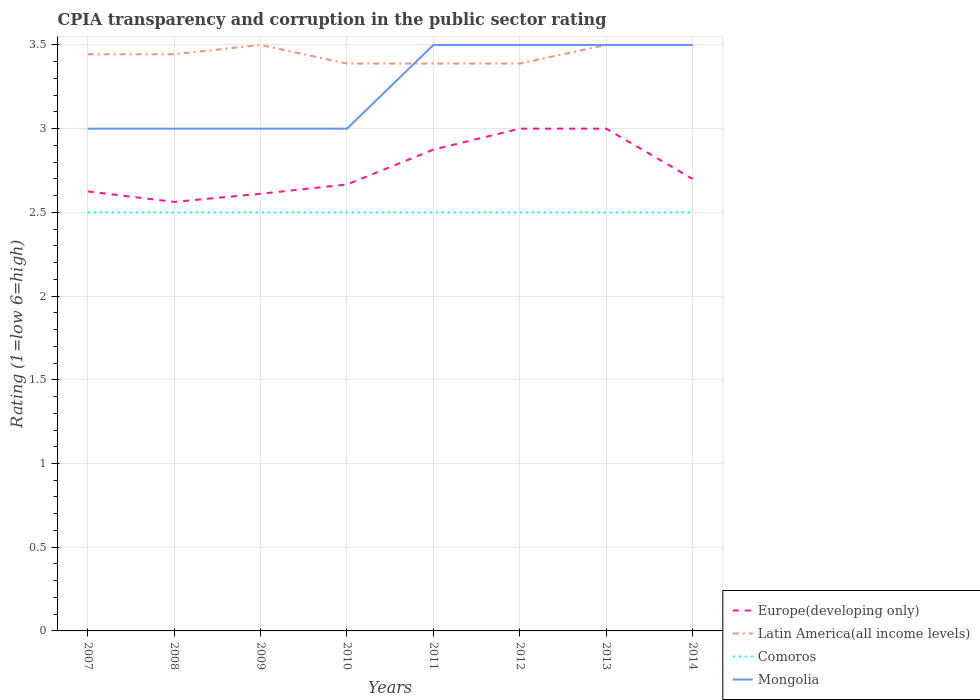How many different coloured lines are there?
Make the answer very short. 4. Does the line corresponding to Comoros intersect with the line corresponding to Latin America(all income levels)?
Provide a succinct answer. No. In which year was the CPIA rating in Latin America(all income levels) maximum?
Your answer should be compact. 2010. What is the difference between the highest and the second highest CPIA rating in Comoros?
Provide a short and direct response. 0. What is the difference between the highest and the lowest CPIA rating in Europe(developing only)?
Your answer should be compact. 3. What is the difference between two consecutive major ticks on the Y-axis?
Your response must be concise. 0.5. Where does the legend appear in the graph?
Your answer should be very brief. Bottom right. How many legend labels are there?
Your response must be concise. 4. How are the legend labels stacked?
Provide a short and direct response. Vertical. What is the title of the graph?
Keep it short and to the point. CPIA transparency and corruption in the public sector rating. What is the label or title of the X-axis?
Your answer should be very brief. Years. What is the Rating (1=low 6=high) of Europe(developing only) in 2007?
Provide a short and direct response. 2.62. What is the Rating (1=low 6=high) in Latin America(all income levels) in 2007?
Your answer should be compact. 3.44. What is the Rating (1=low 6=high) in Comoros in 2007?
Provide a succinct answer. 2.5. What is the Rating (1=low 6=high) in Mongolia in 2007?
Your answer should be compact. 3. What is the Rating (1=low 6=high) of Europe(developing only) in 2008?
Ensure brevity in your answer.  2.56. What is the Rating (1=low 6=high) of Latin America(all income levels) in 2008?
Give a very brief answer. 3.44. What is the Rating (1=low 6=high) of Comoros in 2008?
Give a very brief answer. 2.5. What is the Rating (1=low 6=high) in Mongolia in 2008?
Your response must be concise. 3. What is the Rating (1=low 6=high) in Europe(developing only) in 2009?
Your answer should be very brief. 2.61. What is the Rating (1=low 6=high) in Latin America(all income levels) in 2009?
Provide a succinct answer. 3.5. What is the Rating (1=low 6=high) in Europe(developing only) in 2010?
Offer a terse response. 2.67. What is the Rating (1=low 6=high) of Latin America(all income levels) in 2010?
Provide a succinct answer. 3.39. What is the Rating (1=low 6=high) of Mongolia in 2010?
Your response must be concise. 3. What is the Rating (1=low 6=high) of Europe(developing only) in 2011?
Provide a short and direct response. 2.88. What is the Rating (1=low 6=high) in Latin America(all income levels) in 2011?
Make the answer very short. 3.39. What is the Rating (1=low 6=high) of Europe(developing only) in 2012?
Make the answer very short. 3. What is the Rating (1=low 6=high) of Latin America(all income levels) in 2012?
Offer a terse response. 3.39. What is the Rating (1=low 6=high) of Comoros in 2012?
Your answer should be very brief. 2.5. What is the Rating (1=low 6=high) in Mongolia in 2012?
Provide a short and direct response. 3.5. What is the Rating (1=low 6=high) of Europe(developing only) in 2013?
Offer a very short reply. 3. What is the Rating (1=low 6=high) in Latin America(all income levels) in 2013?
Keep it short and to the point. 3.5. What is the Rating (1=low 6=high) of Europe(developing only) in 2014?
Your response must be concise. 2.7. What is the Rating (1=low 6=high) of Latin America(all income levels) in 2014?
Provide a succinct answer. 3.5. Across all years, what is the minimum Rating (1=low 6=high) of Europe(developing only)?
Your answer should be compact. 2.56. Across all years, what is the minimum Rating (1=low 6=high) in Latin America(all income levels)?
Offer a terse response. 3.39. Across all years, what is the minimum Rating (1=low 6=high) in Mongolia?
Provide a short and direct response. 3. What is the total Rating (1=low 6=high) of Europe(developing only) in the graph?
Your answer should be compact. 22.04. What is the total Rating (1=low 6=high) in Latin America(all income levels) in the graph?
Your response must be concise. 27.56. What is the difference between the Rating (1=low 6=high) in Europe(developing only) in 2007 and that in 2008?
Offer a very short reply. 0.06. What is the difference between the Rating (1=low 6=high) of Latin America(all income levels) in 2007 and that in 2008?
Provide a short and direct response. 0. What is the difference between the Rating (1=low 6=high) in Europe(developing only) in 2007 and that in 2009?
Provide a succinct answer. 0.01. What is the difference between the Rating (1=low 6=high) of Latin America(all income levels) in 2007 and that in 2009?
Ensure brevity in your answer.  -0.06. What is the difference between the Rating (1=low 6=high) of Europe(developing only) in 2007 and that in 2010?
Provide a succinct answer. -0.04. What is the difference between the Rating (1=low 6=high) of Latin America(all income levels) in 2007 and that in 2010?
Provide a succinct answer. 0.06. What is the difference between the Rating (1=low 6=high) in Comoros in 2007 and that in 2010?
Your answer should be compact. 0. What is the difference between the Rating (1=low 6=high) in Mongolia in 2007 and that in 2010?
Provide a short and direct response. 0. What is the difference between the Rating (1=low 6=high) in Europe(developing only) in 2007 and that in 2011?
Offer a terse response. -0.25. What is the difference between the Rating (1=low 6=high) in Latin America(all income levels) in 2007 and that in 2011?
Provide a short and direct response. 0.06. What is the difference between the Rating (1=low 6=high) of Comoros in 2007 and that in 2011?
Offer a very short reply. 0. What is the difference between the Rating (1=low 6=high) in Mongolia in 2007 and that in 2011?
Your response must be concise. -0.5. What is the difference between the Rating (1=low 6=high) in Europe(developing only) in 2007 and that in 2012?
Your answer should be very brief. -0.38. What is the difference between the Rating (1=low 6=high) of Latin America(all income levels) in 2007 and that in 2012?
Offer a terse response. 0.06. What is the difference between the Rating (1=low 6=high) of Comoros in 2007 and that in 2012?
Offer a terse response. 0. What is the difference between the Rating (1=low 6=high) in Mongolia in 2007 and that in 2012?
Your answer should be very brief. -0.5. What is the difference between the Rating (1=low 6=high) in Europe(developing only) in 2007 and that in 2013?
Provide a succinct answer. -0.38. What is the difference between the Rating (1=low 6=high) of Latin America(all income levels) in 2007 and that in 2013?
Give a very brief answer. -0.06. What is the difference between the Rating (1=low 6=high) of Comoros in 2007 and that in 2013?
Make the answer very short. 0. What is the difference between the Rating (1=low 6=high) of Europe(developing only) in 2007 and that in 2014?
Your response must be concise. -0.07. What is the difference between the Rating (1=low 6=high) of Latin America(all income levels) in 2007 and that in 2014?
Keep it short and to the point. -0.06. What is the difference between the Rating (1=low 6=high) in Mongolia in 2007 and that in 2014?
Your response must be concise. -0.5. What is the difference between the Rating (1=low 6=high) of Europe(developing only) in 2008 and that in 2009?
Your response must be concise. -0.05. What is the difference between the Rating (1=low 6=high) in Latin America(all income levels) in 2008 and that in 2009?
Make the answer very short. -0.06. What is the difference between the Rating (1=low 6=high) in Europe(developing only) in 2008 and that in 2010?
Your answer should be very brief. -0.1. What is the difference between the Rating (1=low 6=high) in Latin America(all income levels) in 2008 and that in 2010?
Give a very brief answer. 0.06. What is the difference between the Rating (1=low 6=high) of Europe(developing only) in 2008 and that in 2011?
Offer a terse response. -0.31. What is the difference between the Rating (1=low 6=high) of Latin America(all income levels) in 2008 and that in 2011?
Offer a terse response. 0.06. What is the difference between the Rating (1=low 6=high) of Europe(developing only) in 2008 and that in 2012?
Offer a terse response. -0.44. What is the difference between the Rating (1=low 6=high) in Latin America(all income levels) in 2008 and that in 2012?
Offer a terse response. 0.06. What is the difference between the Rating (1=low 6=high) in Comoros in 2008 and that in 2012?
Ensure brevity in your answer.  0. What is the difference between the Rating (1=low 6=high) in Mongolia in 2008 and that in 2012?
Your answer should be compact. -0.5. What is the difference between the Rating (1=low 6=high) in Europe(developing only) in 2008 and that in 2013?
Offer a terse response. -0.44. What is the difference between the Rating (1=low 6=high) in Latin America(all income levels) in 2008 and that in 2013?
Your answer should be very brief. -0.06. What is the difference between the Rating (1=low 6=high) of Mongolia in 2008 and that in 2013?
Your answer should be compact. -0.5. What is the difference between the Rating (1=low 6=high) of Europe(developing only) in 2008 and that in 2014?
Provide a short and direct response. -0.14. What is the difference between the Rating (1=low 6=high) in Latin America(all income levels) in 2008 and that in 2014?
Provide a succinct answer. -0.06. What is the difference between the Rating (1=low 6=high) in Mongolia in 2008 and that in 2014?
Ensure brevity in your answer.  -0.5. What is the difference between the Rating (1=low 6=high) in Europe(developing only) in 2009 and that in 2010?
Offer a terse response. -0.06. What is the difference between the Rating (1=low 6=high) in Latin America(all income levels) in 2009 and that in 2010?
Provide a short and direct response. 0.11. What is the difference between the Rating (1=low 6=high) of Comoros in 2009 and that in 2010?
Keep it short and to the point. 0. What is the difference between the Rating (1=low 6=high) of Mongolia in 2009 and that in 2010?
Ensure brevity in your answer.  0. What is the difference between the Rating (1=low 6=high) in Europe(developing only) in 2009 and that in 2011?
Keep it short and to the point. -0.26. What is the difference between the Rating (1=low 6=high) of Latin America(all income levels) in 2009 and that in 2011?
Offer a terse response. 0.11. What is the difference between the Rating (1=low 6=high) of Europe(developing only) in 2009 and that in 2012?
Offer a very short reply. -0.39. What is the difference between the Rating (1=low 6=high) in Comoros in 2009 and that in 2012?
Give a very brief answer. 0. What is the difference between the Rating (1=low 6=high) of Europe(developing only) in 2009 and that in 2013?
Keep it short and to the point. -0.39. What is the difference between the Rating (1=low 6=high) of Latin America(all income levels) in 2009 and that in 2013?
Make the answer very short. 0. What is the difference between the Rating (1=low 6=high) in Comoros in 2009 and that in 2013?
Your answer should be very brief. 0. What is the difference between the Rating (1=low 6=high) in Europe(developing only) in 2009 and that in 2014?
Keep it short and to the point. -0.09. What is the difference between the Rating (1=low 6=high) in Latin America(all income levels) in 2009 and that in 2014?
Offer a very short reply. 0. What is the difference between the Rating (1=low 6=high) in Europe(developing only) in 2010 and that in 2011?
Offer a terse response. -0.21. What is the difference between the Rating (1=low 6=high) in Mongolia in 2010 and that in 2011?
Make the answer very short. -0.5. What is the difference between the Rating (1=low 6=high) in Mongolia in 2010 and that in 2012?
Provide a succinct answer. -0.5. What is the difference between the Rating (1=low 6=high) in Latin America(all income levels) in 2010 and that in 2013?
Provide a short and direct response. -0.11. What is the difference between the Rating (1=low 6=high) in Comoros in 2010 and that in 2013?
Make the answer very short. 0. What is the difference between the Rating (1=low 6=high) in Europe(developing only) in 2010 and that in 2014?
Ensure brevity in your answer.  -0.03. What is the difference between the Rating (1=low 6=high) in Latin America(all income levels) in 2010 and that in 2014?
Your response must be concise. -0.11. What is the difference between the Rating (1=low 6=high) in Europe(developing only) in 2011 and that in 2012?
Give a very brief answer. -0.12. What is the difference between the Rating (1=low 6=high) of Comoros in 2011 and that in 2012?
Your answer should be very brief. 0. What is the difference between the Rating (1=low 6=high) of Europe(developing only) in 2011 and that in 2013?
Offer a very short reply. -0.12. What is the difference between the Rating (1=low 6=high) of Latin America(all income levels) in 2011 and that in 2013?
Provide a succinct answer. -0.11. What is the difference between the Rating (1=low 6=high) of Comoros in 2011 and that in 2013?
Ensure brevity in your answer.  0. What is the difference between the Rating (1=low 6=high) of Mongolia in 2011 and that in 2013?
Provide a short and direct response. 0. What is the difference between the Rating (1=low 6=high) in Europe(developing only) in 2011 and that in 2014?
Your answer should be compact. 0.17. What is the difference between the Rating (1=low 6=high) of Latin America(all income levels) in 2011 and that in 2014?
Keep it short and to the point. -0.11. What is the difference between the Rating (1=low 6=high) of Comoros in 2011 and that in 2014?
Your answer should be very brief. 0. What is the difference between the Rating (1=low 6=high) in Latin America(all income levels) in 2012 and that in 2013?
Ensure brevity in your answer.  -0.11. What is the difference between the Rating (1=low 6=high) in Mongolia in 2012 and that in 2013?
Your answer should be very brief. 0. What is the difference between the Rating (1=low 6=high) in Latin America(all income levels) in 2012 and that in 2014?
Offer a terse response. -0.11. What is the difference between the Rating (1=low 6=high) in Comoros in 2012 and that in 2014?
Offer a terse response. 0. What is the difference between the Rating (1=low 6=high) of Mongolia in 2012 and that in 2014?
Your answer should be compact. 0. What is the difference between the Rating (1=low 6=high) in Europe(developing only) in 2013 and that in 2014?
Offer a terse response. 0.3. What is the difference between the Rating (1=low 6=high) of Latin America(all income levels) in 2013 and that in 2014?
Your response must be concise. 0. What is the difference between the Rating (1=low 6=high) of Europe(developing only) in 2007 and the Rating (1=low 6=high) of Latin America(all income levels) in 2008?
Ensure brevity in your answer.  -0.82. What is the difference between the Rating (1=low 6=high) in Europe(developing only) in 2007 and the Rating (1=low 6=high) in Comoros in 2008?
Offer a very short reply. 0.12. What is the difference between the Rating (1=low 6=high) in Europe(developing only) in 2007 and the Rating (1=low 6=high) in Mongolia in 2008?
Provide a short and direct response. -0.38. What is the difference between the Rating (1=low 6=high) in Latin America(all income levels) in 2007 and the Rating (1=low 6=high) in Mongolia in 2008?
Your answer should be compact. 0.44. What is the difference between the Rating (1=low 6=high) of Europe(developing only) in 2007 and the Rating (1=low 6=high) of Latin America(all income levels) in 2009?
Offer a terse response. -0.88. What is the difference between the Rating (1=low 6=high) of Europe(developing only) in 2007 and the Rating (1=low 6=high) of Comoros in 2009?
Your answer should be compact. 0.12. What is the difference between the Rating (1=low 6=high) of Europe(developing only) in 2007 and the Rating (1=low 6=high) of Mongolia in 2009?
Your answer should be compact. -0.38. What is the difference between the Rating (1=low 6=high) in Latin America(all income levels) in 2007 and the Rating (1=low 6=high) in Comoros in 2009?
Your response must be concise. 0.94. What is the difference between the Rating (1=low 6=high) in Latin America(all income levels) in 2007 and the Rating (1=low 6=high) in Mongolia in 2009?
Your answer should be very brief. 0.44. What is the difference between the Rating (1=low 6=high) in Comoros in 2007 and the Rating (1=low 6=high) in Mongolia in 2009?
Provide a succinct answer. -0.5. What is the difference between the Rating (1=low 6=high) of Europe(developing only) in 2007 and the Rating (1=low 6=high) of Latin America(all income levels) in 2010?
Ensure brevity in your answer.  -0.76. What is the difference between the Rating (1=low 6=high) in Europe(developing only) in 2007 and the Rating (1=low 6=high) in Mongolia in 2010?
Keep it short and to the point. -0.38. What is the difference between the Rating (1=low 6=high) of Latin America(all income levels) in 2007 and the Rating (1=low 6=high) of Mongolia in 2010?
Give a very brief answer. 0.44. What is the difference between the Rating (1=low 6=high) of Comoros in 2007 and the Rating (1=low 6=high) of Mongolia in 2010?
Ensure brevity in your answer.  -0.5. What is the difference between the Rating (1=low 6=high) in Europe(developing only) in 2007 and the Rating (1=low 6=high) in Latin America(all income levels) in 2011?
Your answer should be compact. -0.76. What is the difference between the Rating (1=low 6=high) of Europe(developing only) in 2007 and the Rating (1=low 6=high) of Comoros in 2011?
Give a very brief answer. 0.12. What is the difference between the Rating (1=low 6=high) of Europe(developing only) in 2007 and the Rating (1=low 6=high) of Mongolia in 2011?
Make the answer very short. -0.88. What is the difference between the Rating (1=low 6=high) of Latin America(all income levels) in 2007 and the Rating (1=low 6=high) of Comoros in 2011?
Offer a terse response. 0.94. What is the difference between the Rating (1=low 6=high) in Latin America(all income levels) in 2007 and the Rating (1=low 6=high) in Mongolia in 2011?
Your answer should be compact. -0.06. What is the difference between the Rating (1=low 6=high) of Europe(developing only) in 2007 and the Rating (1=low 6=high) of Latin America(all income levels) in 2012?
Give a very brief answer. -0.76. What is the difference between the Rating (1=low 6=high) in Europe(developing only) in 2007 and the Rating (1=low 6=high) in Mongolia in 2012?
Ensure brevity in your answer.  -0.88. What is the difference between the Rating (1=low 6=high) in Latin America(all income levels) in 2007 and the Rating (1=low 6=high) in Comoros in 2012?
Provide a short and direct response. 0.94. What is the difference between the Rating (1=low 6=high) in Latin America(all income levels) in 2007 and the Rating (1=low 6=high) in Mongolia in 2012?
Your answer should be compact. -0.06. What is the difference between the Rating (1=low 6=high) in Comoros in 2007 and the Rating (1=low 6=high) in Mongolia in 2012?
Your answer should be very brief. -1. What is the difference between the Rating (1=low 6=high) of Europe(developing only) in 2007 and the Rating (1=low 6=high) of Latin America(all income levels) in 2013?
Your answer should be very brief. -0.88. What is the difference between the Rating (1=low 6=high) of Europe(developing only) in 2007 and the Rating (1=low 6=high) of Mongolia in 2013?
Provide a short and direct response. -0.88. What is the difference between the Rating (1=low 6=high) in Latin America(all income levels) in 2007 and the Rating (1=low 6=high) in Comoros in 2013?
Your answer should be very brief. 0.94. What is the difference between the Rating (1=low 6=high) in Latin America(all income levels) in 2007 and the Rating (1=low 6=high) in Mongolia in 2013?
Ensure brevity in your answer.  -0.06. What is the difference between the Rating (1=low 6=high) of Europe(developing only) in 2007 and the Rating (1=low 6=high) of Latin America(all income levels) in 2014?
Give a very brief answer. -0.88. What is the difference between the Rating (1=low 6=high) in Europe(developing only) in 2007 and the Rating (1=low 6=high) in Comoros in 2014?
Keep it short and to the point. 0.12. What is the difference between the Rating (1=low 6=high) in Europe(developing only) in 2007 and the Rating (1=low 6=high) in Mongolia in 2014?
Your answer should be very brief. -0.88. What is the difference between the Rating (1=low 6=high) of Latin America(all income levels) in 2007 and the Rating (1=low 6=high) of Mongolia in 2014?
Ensure brevity in your answer.  -0.06. What is the difference between the Rating (1=low 6=high) in Europe(developing only) in 2008 and the Rating (1=low 6=high) in Latin America(all income levels) in 2009?
Your response must be concise. -0.94. What is the difference between the Rating (1=low 6=high) of Europe(developing only) in 2008 and the Rating (1=low 6=high) of Comoros in 2009?
Keep it short and to the point. 0.06. What is the difference between the Rating (1=low 6=high) in Europe(developing only) in 2008 and the Rating (1=low 6=high) in Mongolia in 2009?
Offer a terse response. -0.44. What is the difference between the Rating (1=low 6=high) in Latin America(all income levels) in 2008 and the Rating (1=low 6=high) in Mongolia in 2009?
Keep it short and to the point. 0.44. What is the difference between the Rating (1=low 6=high) in Europe(developing only) in 2008 and the Rating (1=low 6=high) in Latin America(all income levels) in 2010?
Your response must be concise. -0.83. What is the difference between the Rating (1=low 6=high) of Europe(developing only) in 2008 and the Rating (1=low 6=high) of Comoros in 2010?
Give a very brief answer. 0.06. What is the difference between the Rating (1=low 6=high) in Europe(developing only) in 2008 and the Rating (1=low 6=high) in Mongolia in 2010?
Your response must be concise. -0.44. What is the difference between the Rating (1=low 6=high) in Latin America(all income levels) in 2008 and the Rating (1=low 6=high) in Comoros in 2010?
Give a very brief answer. 0.94. What is the difference between the Rating (1=low 6=high) of Latin America(all income levels) in 2008 and the Rating (1=low 6=high) of Mongolia in 2010?
Provide a succinct answer. 0.44. What is the difference between the Rating (1=low 6=high) in Europe(developing only) in 2008 and the Rating (1=low 6=high) in Latin America(all income levels) in 2011?
Your response must be concise. -0.83. What is the difference between the Rating (1=low 6=high) of Europe(developing only) in 2008 and the Rating (1=low 6=high) of Comoros in 2011?
Provide a succinct answer. 0.06. What is the difference between the Rating (1=low 6=high) in Europe(developing only) in 2008 and the Rating (1=low 6=high) in Mongolia in 2011?
Make the answer very short. -0.94. What is the difference between the Rating (1=low 6=high) of Latin America(all income levels) in 2008 and the Rating (1=low 6=high) of Comoros in 2011?
Ensure brevity in your answer.  0.94. What is the difference between the Rating (1=low 6=high) of Latin America(all income levels) in 2008 and the Rating (1=low 6=high) of Mongolia in 2011?
Your answer should be compact. -0.06. What is the difference between the Rating (1=low 6=high) in Comoros in 2008 and the Rating (1=low 6=high) in Mongolia in 2011?
Your answer should be compact. -1. What is the difference between the Rating (1=low 6=high) of Europe(developing only) in 2008 and the Rating (1=low 6=high) of Latin America(all income levels) in 2012?
Ensure brevity in your answer.  -0.83. What is the difference between the Rating (1=low 6=high) in Europe(developing only) in 2008 and the Rating (1=low 6=high) in Comoros in 2012?
Your answer should be very brief. 0.06. What is the difference between the Rating (1=low 6=high) in Europe(developing only) in 2008 and the Rating (1=low 6=high) in Mongolia in 2012?
Keep it short and to the point. -0.94. What is the difference between the Rating (1=low 6=high) in Latin America(all income levels) in 2008 and the Rating (1=low 6=high) in Comoros in 2012?
Your answer should be very brief. 0.94. What is the difference between the Rating (1=low 6=high) of Latin America(all income levels) in 2008 and the Rating (1=low 6=high) of Mongolia in 2012?
Your answer should be very brief. -0.06. What is the difference between the Rating (1=low 6=high) of Comoros in 2008 and the Rating (1=low 6=high) of Mongolia in 2012?
Keep it short and to the point. -1. What is the difference between the Rating (1=low 6=high) of Europe(developing only) in 2008 and the Rating (1=low 6=high) of Latin America(all income levels) in 2013?
Give a very brief answer. -0.94. What is the difference between the Rating (1=low 6=high) in Europe(developing only) in 2008 and the Rating (1=low 6=high) in Comoros in 2013?
Your response must be concise. 0.06. What is the difference between the Rating (1=low 6=high) in Europe(developing only) in 2008 and the Rating (1=low 6=high) in Mongolia in 2013?
Your response must be concise. -0.94. What is the difference between the Rating (1=low 6=high) in Latin America(all income levels) in 2008 and the Rating (1=low 6=high) in Comoros in 2013?
Provide a succinct answer. 0.94. What is the difference between the Rating (1=low 6=high) of Latin America(all income levels) in 2008 and the Rating (1=low 6=high) of Mongolia in 2013?
Your answer should be very brief. -0.06. What is the difference between the Rating (1=low 6=high) in Comoros in 2008 and the Rating (1=low 6=high) in Mongolia in 2013?
Offer a terse response. -1. What is the difference between the Rating (1=low 6=high) in Europe(developing only) in 2008 and the Rating (1=low 6=high) in Latin America(all income levels) in 2014?
Offer a terse response. -0.94. What is the difference between the Rating (1=low 6=high) in Europe(developing only) in 2008 and the Rating (1=low 6=high) in Comoros in 2014?
Your answer should be very brief. 0.06. What is the difference between the Rating (1=low 6=high) of Europe(developing only) in 2008 and the Rating (1=low 6=high) of Mongolia in 2014?
Give a very brief answer. -0.94. What is the difference between the Rating (1=low 6=high) in Latin America(all income levels) in 2008 and the Rating (1=low 6=high) in Mongolia in 2014?
Ensure brevity in your answer.  -0.06. What is the difference between the Rating (1=low 6=high) of Europe(developing only) in 2009 and the Rating (1=low 6=high) of Latin America(all income levels) in 2010?
Provide a short and direct response. -0.78. What is the difference between the Rating (1=low 6=high) in Europe(developing only) in 2009 and the Rating (1=low 6=high) in Comoros in 2010?
Make the answer very short. 0.11. What is the difference between the Rating (1=low 6=high) in Europe(developing only) in 2009 and the Rating (1=low 6=high) in Mongolia in 2010?
Your answer should be very brief. -0.39. What is the difference between the Rating (1=low 6=high) in Latin America(all income levels) in 2009 and the Rating (1=low 6=high) in Comoros in 2010?
Give a very brief answer. 1. What is the difference between the Rating (1=low 6=high) in Comoros in 2009 and the Rating (1=low 6=high) in Mongolia in 2010?
Your answer should be compact. -0.5. What is the difference between the Rating (1=low 6=high) of Europe(developing only) in 2009 and the Rating (1=low 6=high) of Latin America(all income levels) in 2011?
Your answer should be compact. -0.78. What is the difference between the Rating (1=low 6=high) of Europe(developing only) in 2009 and the Rating (1=low 6=high) of Mongolia in 2011?
Offer a terse response. -0.89. What is the difference between the Rating (1=low 6=high) in Europe(developing only) in 2009 and the Rating (1=low 6=high) in Latin America(all income levels) in 2012?
Provide a short and direct response. -0.78. What is the difference between the Rating (1=low 6=high) of Europe(developing only) in 2009 and the Rating (1=low 6=high) of Mongolia in 2012?
Give a very brief answer. -0.89. What is the difference between the Rating (1=low 6=high) in Latin America(all income levels) in 2009 and the Rating (1=low 6=high) in Comoros in 2012?
Keep it short and to the point. 1. What is the difference between the Rating (1=low 6=high) of Europe(developing only) in 2009 and the Rating (1=low 6=high) of Latin America(all income levels) in 2013?
Provide a succinct answer. -0.89. What is the difference between the Rating (1=low 6=high) in Europe(developing only) in 2009 and the Rating (1=low 6=high) in Mongolia in 2013?
Your answer should be compact. -0.89. What is the difference between the Rating (1=low 6=high) in Latin America(all income levels) in 2009 and the Rating (1=low 6=high) in Mongolia in 2013?
Offer a terse response. 0. What is the difference between the Rating (1=low 6=high) of Comoros in 2009 and the Rating (1=low 6=high) of Mongolia in 2013?
Ensure brevity in your answer.  -1. What is the difference between the Rating (1=low 6=high) in Europe(developing only) in 2009 and the Rating (1=low 6=high) in Latin America(all income levels) in 2014?
Your response must be concise. -0.89. What is the difference between the Rating (1=low 6=high) in Europe(developing only) in 2009 and the Rating (1=low 6=high) in Mongolia in 2014?
Keep it short and to the point. -0.89. What is the difference between the Rating (1=low 6=high) in Latin America(all income levels) in 2009 and the Rating (1=low 6=high) in Mongolia in 2014?
Offer a terse response. 0. What is the difference between the Rating (1=low 6=high) in Europe(developing only) in 2010 and the Rating (1=low 6=high) in Latin America(all income levels) in 2011?
Offer a very short reply. -0.72. What is the difference between the Rating (1=low 6=high) in Europe(developing only) in 2010 and the Rating (1=low 6=high) in Comoros in 2011?
Offer a very short reply. 0.17. What is the difference between the Rating (1=low 6=high) in Europe(developing only) in 2010 and the Rating (1=low 6=high) in Mongolia in 2011?
Give a very brief answer. -0.83. What is the difference between the Rating (1=low 6=high) in Latin America(all income levels) in 2010 and the Rating (1=low 6=high) in Comoros in 2011?
Provide a short and direct response. 0.89. What is the difference between the Rating (1=low 6=high) in Latin America(all income levels) in 2010 and the Rating (1=low 6=high) in Mongolia in 2011?
Offer a terse response. -0.11. What is the difference between the Rating (1=low 6=high) of Comoros in 2010 and the Rating (1=low 6=high) of Mongolia in 2011?
Your answer should be very brief. -1. What is the difference between the Rating (1=low 6=high) of Europe(developing only) in 2010 and the Rating (1=low 6=high) of Latin America(all income levels) in 2012?
Offer a very short reply. -0.72. What is the difference between the Rating (1=low 6=high) of Europe(developing only) in 2010 and the Rating (1=low 6=high) of Comoros in 2012?
Offer a very short reply. 0.17. What is the difference between the Rating (1=low 6=high) of Europe(developing only) in 2010 and the Rating (1=low 6=high) of Mongolia in 2012?
Provide a succinct answer. -0.83. What is the difference between the Rating (1=low 6=high) of Latin America(all income levels) in 2010 and the Rating (1=low 6=high) of Comoros in 2012?
Offer a very short reply. 0.89. What is the difference between the Rating (1=low 6=high) of Latin America(all income levels) in 2010 and the Rating (1=low 6=high) of Mongolia in 2012?
Offer a very short reply. -0.11. What is the difference between the Rating (1=low 6=high) in Europe(developing only) in 2010 and the Rating (1=low 6=high) in Latin America(all income levels) in 2013?
Ensure brevity in your answer.  -0.83. What is the difference between the Rating (1=low 6=high) in Europe(developing only) in 2010 and the Rating (1=low 6=high) in Mongolia in 2013?
Your answer should be compact. -0.83. What is the difference between the Rating (1=low 6=high) in Latin America(all income levels) in 2010 and the Rating (1=low 6=high) in Mongolia in 2013?
Make the answer very short. -0.11. What is the difference between the Rating (1=low 6=high) of Europe(developing only) in 2010 and the Rating (1=low 6=high) of Mongolia in 2014?
Offer a very short reply. -0.83. What is the difference between the Rating (1=low 6=high) in Latin America(all income levels) in 2010 and the Rating (1=low 6=high) in Comoros in 2014?
Your response must be concise. 0.89. What is the difference between the Rating (1=low 6=high) of Latin America(all income levels) in 2010 and the Rating (1=low 6=high) of Mongolia in 2014?
Provide a short and direct response. -0.11. What is the difference between the Rating (1=low 6=high) in Comoros in 2010 and the Rating (1=low 6=high) in Mongolia in 2014?
Provide a succinct answer. -1. What is the difference between the Rating (1=low 6=high) of Europe(developing only) in 2011 and the Rating (1=low 6=high) of Latin America(all income levels) in 2012?
Your answer should be very brief. -0.51. What is the difference between the Rating (1=low 6=high) of Europe(developing only) in 2011 and the Rating (1=low 6=high) of Mongolia in 2012?
Give a very brief answer. -0.62. What is the difference between the Rating (1=low 6=high) of Latin America(all income levels) in 2011 and the Rating (1=low 6=high) of Mongolia in 2012?
Your response must be concise. -0.11. What is the difference between the Rating (1=low 6=high) in Comoros in 2011 and the Rating (1=low 6=high) in Mongolia in 2012?
Ensure brevity in your answer.  -1. What is the difference between the Rating (1=low 6=high) in Europe(developing only) in 2011 and the Rating (1=low 6=high) in Latin America(all income levels) in 2013?
Offer a very short reply. -0.62. What is the difference between the Rating (1=low 6=high) of Europe(developing only) in 2011 and the Rating (1=low 6=high) of Mongolia in 2013?
Offer a very short reply. -0.62. What is the difference between the Rating (1=low 6=high) in Latin America(all income levels) in 2011 and the Rating (1=low 6=high) in Comoros in 2013?
Make the answer very short. 0.89. What is the difference between the Rating (1=low 6=high) of Latin America(all income levels) in 2011 and the Rating (1=low 6=high) of Mongolia in 2013?
Provide a short and direct response. -0.11. What is the difference between the Rating (1=low 6=high) in Comoros in 2011 and the Rating (1=low 6=high) in Mongolia in 2013?
Provide a short and direct response. -1. What is the difference between the Rating (1=low 6=high) of Europe(developing only) in 2011 and the Rating (1=low 6=high) of Latin America(all income levels) in 2014?
Offer a terse response. -0.62. What is the difference between the Rating (1=low 6=high) in Europe(developing only) in 2011 and the Rating (1=low 6=high) in Comoros in 2014?
Offer a very short reply. 0.38. What is the difference between the Rating (1=low 6=high) of Europe(developing only) in 2011 and the Rating (1=low 6=high) of Mongolia in 2014?
Give a very brief answer. -0.62. What is the difference between the Rating (1=low 6=high) of Latin America(all income levels) in 2011 and the Rating (1=low 6=high) of Comoros in 2014?
Provide a short and direct response. 0.89. What is the difference between the Rating (1=low 6=high) in Latin America(all income levels) in 2011 and the Rating (1=low 6=high) in Mongolia in 2014?
Offer a terse response. -0.11. What is the difference between the Rating (1=low 6=high) in Comoros in 2011 and the Rating (1=low 6=high) in Mongolia in 2014?
Offer a very short reply. -1. What is the difference between the Rating (1=low 6=high) of Europe(developing only) in 2012 and the Rating (1=low 6=high) of Comoros in 2013?
Offer a terse response. 0.5. What is the difference between the Rating (1=low 6=high) of Europe(developing only) in 2012 and the Rating (1=low 6=high) of Mongolia in 2013?
Offer a very short reply. -0.5. What is the difference between the Rating (1=low 6=high) in Latin America(all income levels) in 2012 and the Rating (1=low 6=high) in Mongolia in 2013?
Your response must be concise. -0.11. What is the difference between the Rating (1=low 6=high) in Europe(developing only) in 2012 and the Rating (1=low 6=high) in Latin America(all income levels) in 2014?
Your answer should be compact. -0.5. What is the difference between the Rating (1=low 6=high) of Europe(developing only) in 2012 and the Rating (1=low 6=high) of Comoros in 2014?
Offer a terse response. 0.5. What is the difference between the Rating (1=low 6=high) of Europe(developing only) in 2012 and the Rating (1=low 6=high) of Mongolia in 2014?
Make the answer very short. -0.5. What is the difference between the Rating (1=low 6=high) of Latin America(all income levels) in 2012 and the Rating (1=low 6=high) of Comoros in 2014?
Give a very brief answer. 0.89. What is the difference between the Rating (1=low 6=high) in Latin America(all income levels) in 2012 and the Rating (1=low 6=high) in Mongolia in 2014?
Provide a short and direct response. -0.11. What is the difference between the Rating (1=low 6=high) in Comoros in 2012 and the Rating (1=low 6=high) in Mongolia in 2014?
Make the answer very short. -1. What is the difference between the Rating (1=low 6=high) in Europe(developing only) in 2013 and the Rating (1=low 6=high) in Comoros in 2014?
Ensure brevity in your answer.  0.5. What is the difference between the Rating (1=low 6=high) of Europe(developing only) in 2013 and the Rating (1=low 6=high) of Mongolia in 2014?
Your response must be concise. -0.5. What is the difference between the Rating (1=low 6=high) in Latin America(all income levels) in 2013 and the Rating (1=low 6=high) in Comoros in 2014?
Offer a very short reply. 1. What is the difference between the Rating (1=low 6=high) of Latin America(all income levels) in 2013 and the Rating (1=low 6=high) of Mongolia in 2014?
Ensure brevity in your answer.  0. What is the difference between the Rating (1=low 6=high) in Comoros in 2013 and the Rating (1=low 6=high) in Mongolia in 2014?
Ensure brevity in your answer.  -1. What is the average Rating (1=low 6=high) of Europe(developing only) per year?
Give a very brief answer. 2.75. What is the average Rating (1=low 6=high) of Latin America(all income levels) per year?
Ensure brevity in your answer.  3.44. In the year 2007, what is the difference between the Rating (1=low 6=high) of Europe(developing only) and Rating (1=low 6=high) of Latin America(all income levels)?
Give a very brief answer. -0.82. In the year 2007, what is the difference between the Rating (1=low 6=high) in Europe(developing only) and Rating (1=low 6=high) in Mongolia?
Your answer should be very brief. -0.38. In the year 2007, what is the difference between the Rating (1=low 6=high) in Latin America(all income levels) and Rating (1=low 6=high) in Comoros?
Offer a terse response. 0.94. In the year 2007, what is the difference between the Rating (1=low 6=high) in Latin America(all income levels) and Rating (1=low 6=high) in Mongolia?
Ensure brevity in your answer.  0.44. In the year 2008, what is the difference between the Rating (1=low 6=high) in Europe(developing only) and Rating (1=low 6=high) in Latin America(all income levels)?
Offer a very short reply. -0.88. In the year 2008, what is the difference between the Rating (1=low 6=high) of Europe(developing only) and Rating (1=low 6=high) of Comoros?
Your answer should be very brief. 0.06. In the year 2008, what is the difference between the Rating (1=low 6=high) in Europe(developing only) and Rating (1=low 6=high) in Mongolia?
Make the answer very short. -0.44. In the year 2008, what is the difference between the Rating (1=low 6=high) in Latin America(all income levels) and Rating (1=low 6=high) in Comoros?
Offer a terse response. 0.94. In the year 2008, what is the difference between the Rating (1=low 6=high) of Latin America(all income levels) and Rating (1=low 6=high) of Mongolia?
Ensure brevity in your answer.  0.44. In the year 2008, what is the difference between the Rating (1=low 6=high) in Comoros and Rating (1=low 6=high) in Mongolia?
Provide a short and direct response. -0.5. In the year 2009, what is the difference between the Rating (1=low 6=high) of Europe(developing only) and Rating (1=low 6=high) of Latin America(all income levels)?
Provide a short and direct response. -0.89. In the year 2009, what is the difference between the Rating (1=low 6=high) in Europe(developing only) and Rating (1=low 6=high) in Mongolia?
Your response must be concise. -0.39. In the year 2009, what is the difference between the Rating (1=low 6=high) of Latin America(all income levels) and Rating (1=low 6=high) of Mongolia?
Give a very brief answer. 0.5. In the year 2009, what is the difference between the Rating (1=low 6=high) of Comoros and Rating (1=low 6=high) of Mongolia?
Your answer should be compact. -0.5. In the year 2010, what is the difference between the Rating (1=low 6=high) in Europe(developing only) and Rating (1=low 6=high) in Latin America(all income levels)?
Offer a terse response. -0.72. In the year 2010, what is the difference between the Rating (1=low 6=high) in Europe(developing only) and Rating (1=low 6=high) in Comoros?
Make the answer very short. 0.17. In the year 2010, what is the difference between the Rating (1=low 6=high) in Europe(developing only) and Rating (1=low 6=high) in Mongolia?
Your response must be concise. -0.33. In the year 2010, what is the difference between the Rating (1=low 6=high) in Latin America(all income levels) and Rating (1=low 6=high) in Mongolia?
Ensure brevity in your answer.  0.39. In the year 2011, what is the difference between the Rating (1=low 6=high) in Europe(developing only) and Rating (1=low 6=high) in Latin America(all income levels)?
Ensure brevity in your answer.  -0.51. In the year 2011, what is the difference between the Rating (1=low 6=high) of Europe(developing only) and Rating (1=low 6=high) of Comoros?
Provide a succinct answer. 0.38. In the year 2011, what is the difference between the Rating (1=low 6=high) in Europe(developing only) and Rating (1=low 6=high) in Mongolia?
Offer a very short reply. -0.62. In the year 2011, what is the difference between the Rating (1=low 6=high) in Latin America(all income levels) and Rating (1=low 6=high) in Comoros?
Provide a succinct answer. 0.89. In the year 2011, what is the difference between the Rating (1=low 6=high) of Latin America(all income levels) and Rating (1=low 6=high) of Mongolia?
Your answer should be compact. -0.11. In the year 2011, what is the difference between the Rating (1=low 6=high) in Comoros and Rating (1=low 6=high) in Mongolia?
Offer a very short reply. -1. In the year 2012, what is the difference between the Rating (1=low 6=high) of Europe(developing only) and Rating (1=low 6=high) of Latin America(all income levels)?
Provide a short and direct response. -0.39. In the year 2012, what is the difference between the Rating (1=low 6=high) in Latin America(all income levels) and Rating (1=low 6=high) in Mongolia?
Your response must be concise. -0.11. In the year 2013, what is the difference between the Rating (1=low 6=high) in Europe(developing only) and Rating (1=low 6=high) in Comoros?
Your answer should be very brief. 0.5. In the year 2013, what is the difference between the Rating (1=low 6=high) in Europe(developing only) and Rating (1=low 6=high) in Mongolia?
Make the answer very short. -0.5. In the year 2013, what is the difference between the Rating (1=low 6=high) of Latin America(all income levels) and Rating (1=low 6=high) of Mongolia?
Your response must be concise. 0. In the year 2013, what is the difference between the Rating (1=low 6=high) of Comoros and Rating (1=low 6=high) of Mongolia?
Offer a terse response. -1. In the year 2014, what is the difference between the Rating (1=low 6=high) of Europe(developing only) and Rating (1=low 6=high) of Latin America(all income levels)?
Make the answer very short. -0.8. In the year 2014, what is the difference between the Rating (1=low 6=high) of Europe(developing only) and Rating (1=low 6=high) of Comoros?
Make the answer very short. 0.2. In the year 2014, what is the difference between the Rating (1=low 6=high) of Latin America(all income levels) and Rating (1=low 6=high) of Comoros?
Make the answer very short. 1. In the year 2014, what is the difference between the Rating (1=low 6=high) of Latin America(all income levels) and Rating (1=low 6=high) of Mongolia?
Keep it short and to the point. 0. In the year 2014, what is the difference between the Rating (1=low 6=high) of Comoros and Rating (1=low 6=high) of Mongolia?
Offer a terse response. -1. What is the ratio of the Rating (1=low 6=high) of Europe(developing only) in 2007 to that in 2008?
Make the answer very short. 1.02. What is the ratio of the Rating (1=low 6=high) in Latin America(all income levels) in 2007 to that in 2008?
Your response must be concise. 1. What is the ratio of the Rating (1=low 6=high) in Latin America(all income levels) in 2007 to that in 2009?
Your answer should be compact. 0.98. What is the ratio of the Rating (1=low 6=high) of Mongolia in 2007 to that in 2009?
Make the answer very short. 1. What is the ratio of the Rating (1=low 6=high) of Europe(developing only) in 2007 to that in 2010?
Your answer should be compact. 0.98. What is the ratio of the Rating (1=low 6=high) in Latin America(all income levels) in 2007 to that in 2010?
Make the answer very short. 1.02. What is the ratio of the Rating (1=low 6=high) in Comoros in 2007 to that in 2010?
Make the answer very short. 1. What is the ratio of the Rating (1=low 6=high) in Mongolia in 2007 to that in 2010?
Keep it short and to the point. 1. What is the ratio of the Rating (1=low 6=high) in Europe(developing only) in 2007 to that in 2011?
Offer a terse response. 0.91. What is the ratio of the Rating (1=low 6=high) in Latin America(all income levels) in 2007 to that in 2011?
Make the answer very short. 1.02. What is the ratio of the Rating (1=low 6=high) of Mongolia in 2007 to that in 2011?
Give a very brief answer. 0.86. What is the ratio of the Rating (1=low 6=high) of Latin America(all income levels) in 2007 to that in 2012?
Ensure brevity in your answer.  1.02. What is the ratio of the Rating (1=low 6=high) of Latin America(all income levels) in 2007 to that in 2013?
Offer a very short reply. 0.98. What is the ratio of the Rating (1=low 6=high) in Mongolia in 2007 to that in 2013?
Give a very brief answer. 0.86. What is the ratio of the Rating (1=low 6=high) of Europe(developing only) in 2007 to that in 2014?
Provide a short and direct response. 0.97. What is the ratio of the Rating (1=low 6=high) of Latin America(all income levels) in 2007 to that in 2014?
Your answer should be very brief. 0.98. What is the ratio of the Rating (1=low 6=high) in Comoros in 2007 to that in 2014?
Offer a very short reply. 1. What is the ratio of the Rating (1=low 6=high) in Europe(developing only) in 2008 to that in 2009?
Ensure brevity in your answer.  0.98. What is the ratio of the Rating (1=low 6=high) of Latin America(all income levels) in 2008 to that in 2009?
Make the answer very short. 0.98. What is the ratio of the Rating (1=low 6=high) in Mongolia in 2008 to that in 2009?
Your answer should be compact. 1. What is the ratio of the Rating (1=low 6=high) of Europe(developing only) in 2008 to that in 2010?
Give a very brief answer. 0.96. What is the ratio of the Rating (1=low 6=high) in Latin America(all income levels) in 2008 to that in 2010?
Your answer should be very brief. 1.02. What is the ratio of the Rating (1=low 6=high) in Europe(developing only) in 2008 to that in 2011?
Your answer should be very brief. 0.89. What is the ratio of the Rating (1=low 6=high) of Latin America(all income levels) in 2008 to that in 2011?
Offer a terse response. 1.02. What is the ratio of the Rating (1=low 6=high) of Europe(developing only) in 2008 to that in 2012?
Offer a terse response. 0.85. What is the ratio of the Rating (1=low 6=high) of Latin America(all income levels) in 2008 to that in 2012?
Offer a terse response. 1.02. What is the ratio of the Rating (1=low 6=high) of Comoros in 2008 to that in 2012?
Make the answer very short. 1. What is the ratio of the Rating (1=low 6=high) of Europe(developing only) in 2008 to that in 2013?
Offer a terse response. 0.85. What is the ratio of the Rating (1=low 6=high) of Latin America(all income levels) in 2008 to that in 2013?
Give a very brief answer. 0.98. What is the ratio of the Rating (1=low 6=high) of Comoros in 2008 to that in 2013?
Offer a terse response. 1. What is the ratio of the Rating (1=low 6=high) of Europe(developing only) in 2008 to that in 2014?
Your response must be concise. 0.95. What is the ratio of the Rating (1=low 6=high) of Latin America(all income levels) in 2008 to that in 2014?
Ensure brevity in your answer.  0.98. What is the ratio of the Rating (1=low 6=high) in Comoros in 2008 to that in 2014?
Provide a short and direct response. 1. What is the ratio of the Rating (1=low 6=high) in Mongolia in 2008 to that in 2014?
Your answer should be compact. 0.86. What is the ratio of the Rating (1=low 6=high) in Europe(developing only) in 2009 to that in 2010?
Your response must be concise. 0.98. What is the ratio of the Rating (1=low 6=high) of Latin America(all income levels) in 2009 to that in 2010?
Give a very brief answer. 1.03. What is the ratio of the Rating (1=low 6=high) of Mongolia in 2009 to that in 2010?
Offer a very short reply. 1. What is the ratio of the Rating (1=low 6=high) in Europe(developing only) in 2009 to that in 2011?
Offer a very short reply. 0.91. What is the ratio of the Rating (1=low 6=high) in Latin America(all income levels) in 2009 to that in 2011?
Offer a very short reply. 1.03. What is the ratio of the Rating (1=low 6=high) of Mongolia in 2009 to that in 2011?
Offer a very short reply. 0.86. What is the ratio of the Rating (1=low 6=high) of Europe(developing only) in 2009 to that in 2012?
Give a very brief answer. 0.87. What is the ratio of the Rating (1=low 6=high) of Latin America(all income levels) in 2009 to that in 2012?
Your answer should be compact. 1.03. What is the ratio of the Rating (1=low 6=high) of Mongolia in 2009 to that in 2012?
Offer a very short reply. 0.86. What is the ratio of the Rating (1=low 6=high) of Europe(developing only) in 2009 to that in 2013?
Give a very brief answer. 0.87. What is the ratio of the Rating (1=low 6=high) of Latin America(all income levels) in 2009 to that in 2013?
Ensure brevity in your answer.  1. What is the ratio of the Rating (1=low 6=high) of Comoros in 2009 to that in 2013?
Your answer should be compact. 1. What is the ratio of the Rating (1=low 6=high) in Mongolia in 2009 to that in 2013?
Ensure brevity in your answer.  0.86. What is the ratio of the Rating (1=low 6=high) in Europe(developing only) in 2009 to that in 2014?
Provide a short and direct response. 0.97. What is the ratio of the Rating (1=low 6=high) of Latin America(all income levels) in 2009 to that in 2014?
Make the answer very short. 1. What is the ratio of the Rating (1=low 6=high) in Europe(developing only) in 2010 to that in 2011?
Ensure brevity in your answer.  0.93. What is the ratio of the Rating (1=low 6=high) in Comoros in 2010 to that in 2011?
Provide a succinct answer. 1. What is the ratio of the Rating (1=low 6=high) in Mongolia in 2010 to that in 2011?
Provide a short and direct response. 0.86. What is the ratio of the Rating (1=low 6=high) of Latin America(all income levels) in 2010 to that in 2012?
Your answer should be compact. 1. What is the ratio of the Rating (1=low 6=high) of Comoros in 2010 to that in 2012?
Offer a terse response. 1. What is the ratio of the Rating (1=low 6=high) of Europe(developing only) in 2010 to that in 2013?
Offer a terse response. 0.89. What is the ratio of the Rating (1=low 6=high) in Latin America(all income levels) in 2010 to that in 2013?
Offer a terse response. 0.97. What is the ratio of the Rating (1=low 6=high) in Europe(developing only) in 2010 to that in 2014?
Offer a terse response. 0.99. What is the ratio of the Rating (1=low 6=high) of Latin America(all income levels) in 2010 to that in 2014?
Your answer should be compact. 0.97. What is the ratio of the Rating (1=low 6=high) in Europe(developing only) in 2011 to that in 2012?
Ensure brevity in your answer.  0.96. What is the ratio of the Rating (1=low 6=high) in Latin America(all income levels) in 2011 to that in 2012?
Ensure brevity in your answer.  1. What is the ratio of the Rating (1=low 6=high) of Europe(developing only) in 2011 to that in 2013?
Make the answer very short. 0.96. What is the ratio of the Rating (1=low 6=high) of Latin America(all income levels) in 2011 to that in 2013?
Your response must be concise. 0.97. What is the ratio of the Rating (1=low 6=high) of Europe(developing only) in 2011 to that in 2014?
Offer a very short reply. 1.06. What is the ratio of the Rating (1=low 6=high) of Latin America(all income levels) in 2011 to that in 2014?
Your response must be concise. 0.97. What is the ratio of the Rating (1=low 6=high) of Comoros in 2011 to that in 2014?
Provide a short and direct response. 1. What is the ratio of the Rating (1=low 6=high) of Mongolia in 2011 to that in 2014?
Your answer should be very brief. 1. What is the ratio of the Rating (1=low 6=high) in Latin America(all income levels) in 2012 to that in 2013?
Keep it short and to the point. 0.97. What is the ratio of the Rating (1=low 6=high) in Europe(developing only) in 2012 to that in 2014?
Your answer should be very brief. 1.11. What is the ratio of the Rating (1=low 6=high) in Latin America(all income levels) in 2012 to that in 2014?
Offer a very short reply. 0.97. What is the ratio of the Rating (1=low 6=high) in Comoros in 2012 to that in 2014?
Your answer should be very brief. 1. What is the ratio of the Rating (1=low 6=high) of Europe(developing only) in 2013 to that in 2014?
Provide a succinct answer. 1.11. What is the ratio of the Rating (1=low 6=high) in Comoros in 2013 to that in 2014?
Provide a short and direct response. 1. What is the difference between the highest and the second highest Rating (1=low 6=high) in Comoros?
Keep it short and to the point. 0. What is the difference between the highest and the second highest Rating (1=low 6=high) of Mongolia?
Your answer should be very brief. 0. What is the difference between the highest and the lowest Rating (1=low 6=high) in Europe(developing only)?
Make the answer very short. 0.44. What is the difference between the highest and the lowest Rating (1=low 6=high) of Latin America(all income levels)?
Your answer should be compact. 0.11. What is the difference between the highest and the lowest Rating (1=low 6=high) of Mongolia?
Your answer should be compact. 0.5. 